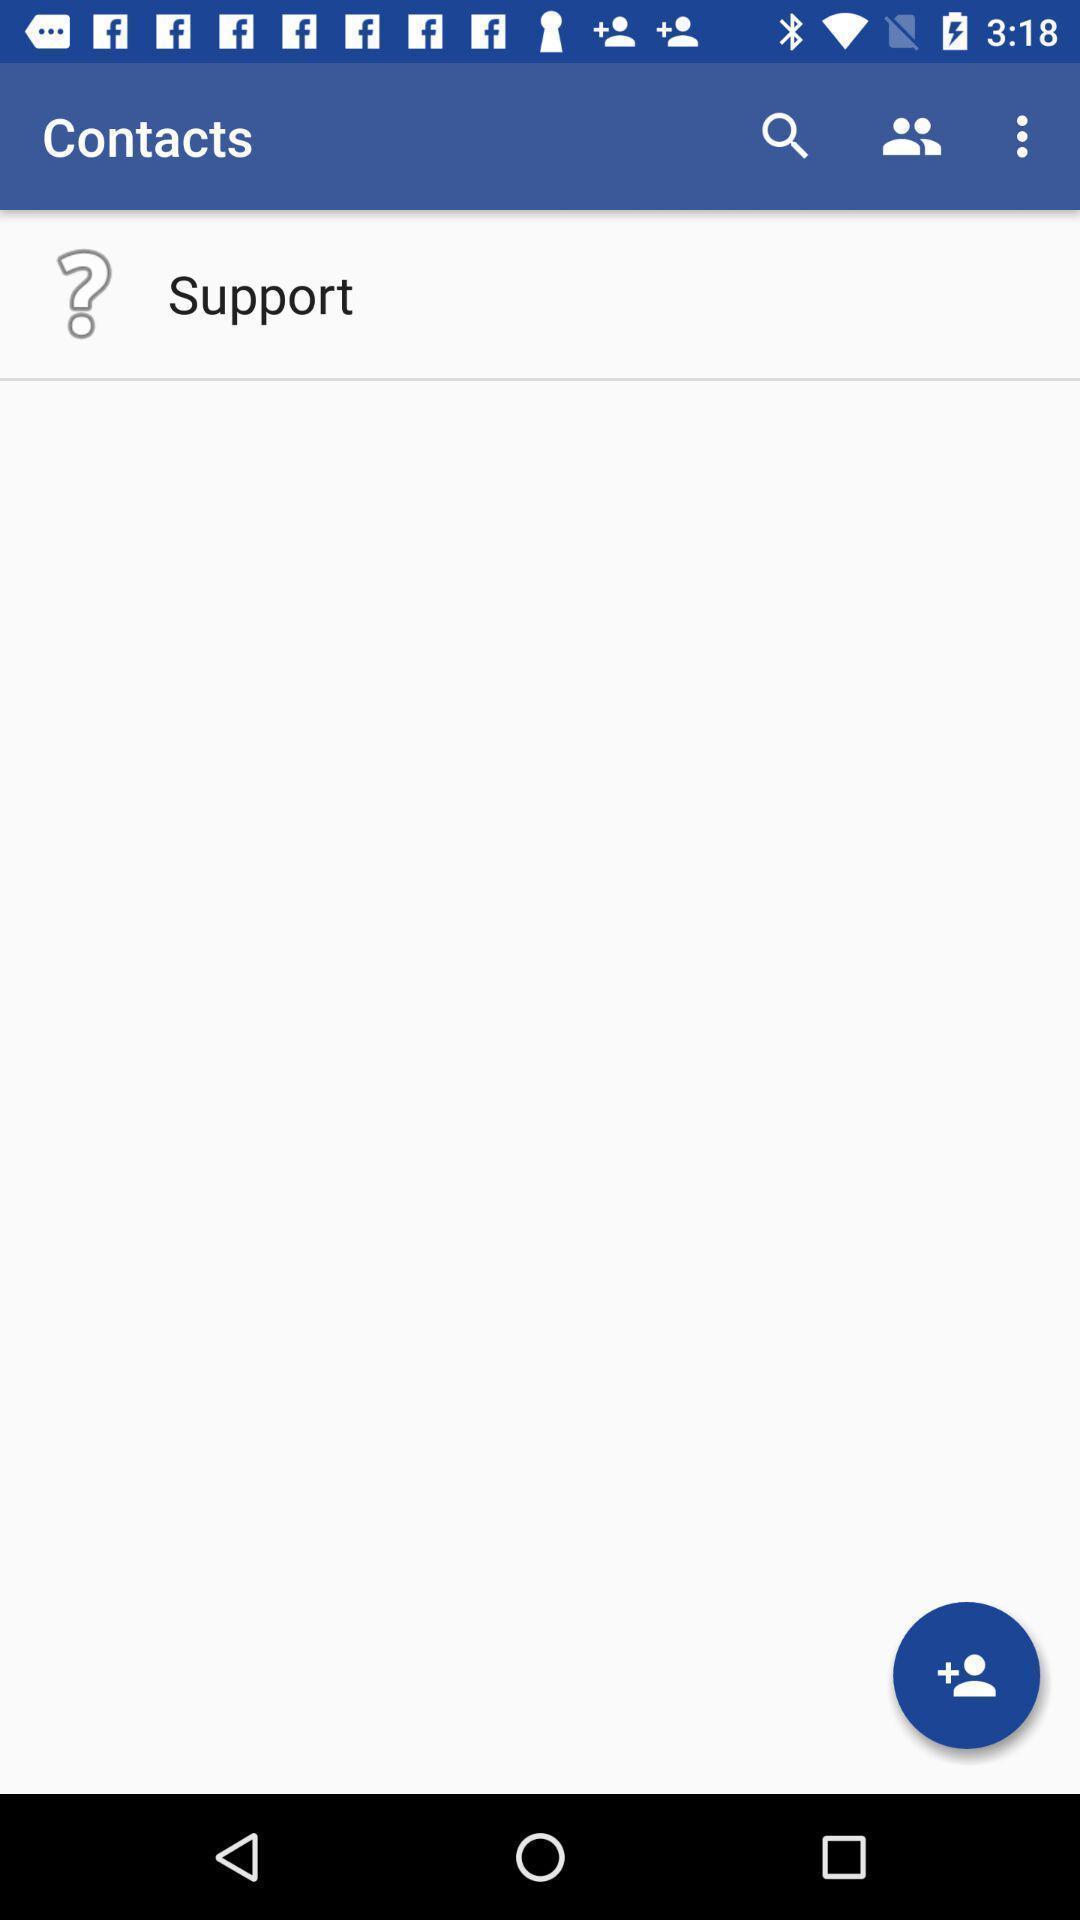Describe the key features of this screenshot. Screen shows contacts details. 